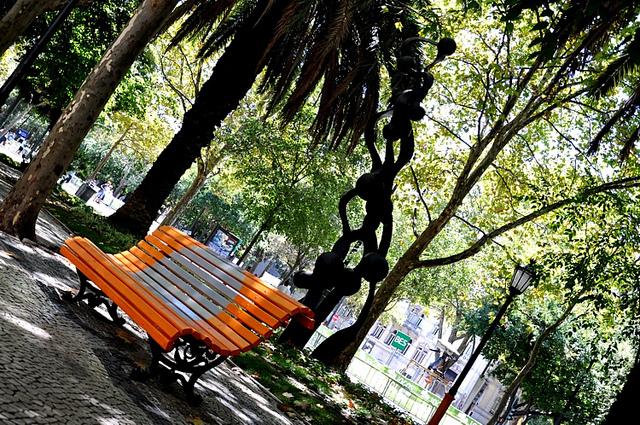Does this bench need painted?
Concise answer only. No. Are any palm trees in the picture?
Give a very brief answer. Yes. What colors are the seating area?
Be succinct. Orange and gray. 